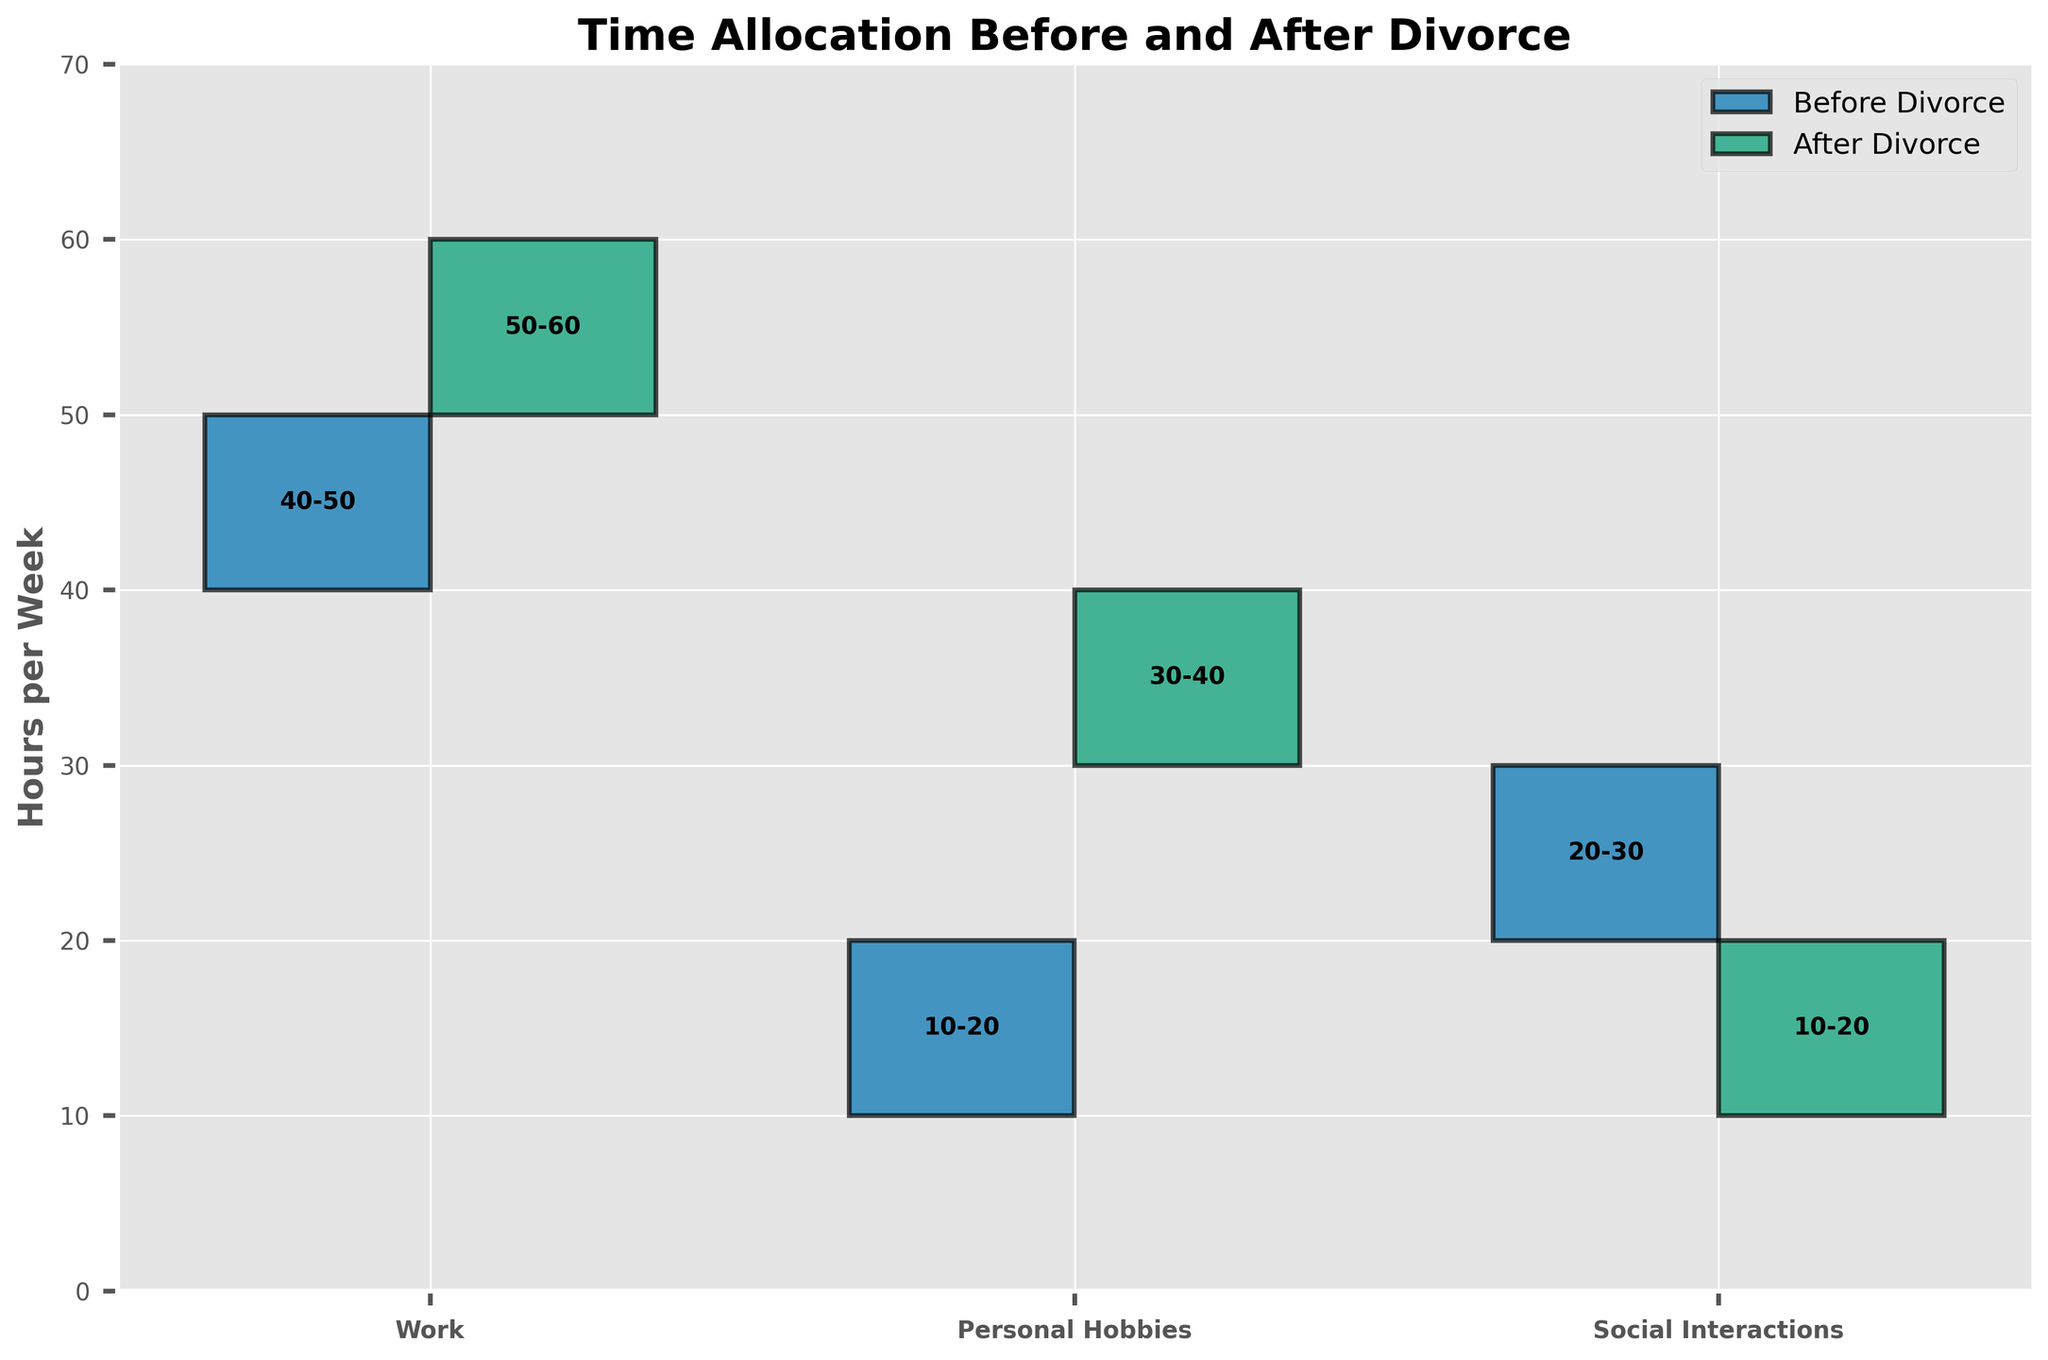What's the title of the figure? The title is displayed at the top of the figure. It reads "Time Allocation Before and After Divorce".
Answer: Time Allocation Before and After Divorce What activity saw the biggest increase in hours after the divorce? Compare the min and max values of each activity before and after the divorce. Personal Hobbies increased from 10-20 to 30-40 hours.
Answer: Personal Hobbies What's the range of hours dedicated to work after the divorce? The range of hours is shown by the bars labeled "After Divorce" under the "Work" category. It spans from 50 to 60 hours.
Answer: 50-60 hours How many activities are compared in the figure? Count the unique labels on the x-axis, which represent each activity.
Answer: 3 activities Which activity experienced the largest decrease in hours after the divorce? Compare the min and max values for each activity before and after the divorce, Social Interactions decreased from 20-30 hours to 10-20 hours.
Answer: Social Interactions How much time, on average, did you spend on personal hobbies before the divorce? The average can be found by taking the midpoint between the minimum and maximum values for Personal Hobbies before divorce (10 and 20). This midpoint is (10+20)/2 = 15 hours.
Answer: 15 hours Which activity had a more consistent (narrower range) time allocation before than after the divorce? Compare the range width (max value minus min value) for each activity before and after the divorce. The range for Personal Hobbies was narrower before (10) compared to after (10).
Answer: Personal Hobbies Do you spend less or more time on social interactions after the divorce compared to before? Compare the min and max value ranges of the "Social Interactions" before and after the divorce. After the divorce, the range is lower (10-20 hours) compared to before (20-30 hours).
Answer: Less What was the total range covered by work, personal hobbies, and social interactions before the divorce? Add the min and max values of all three activities before the divorce: Work (40-50), Personal Hobbies (10-20), Social Interactions (20-30). The total minimum is 40+10+20 = 70, and the total maximum is 50+20+30 = 100.
Answer: 70-100 Looking at the ranges, which activity has the most variability after the divorce? Identify which activity has the largest difference between min and max values after the divorce. Both Work and Personal Hobbies have a range of 10 hours each, while Social Interactions has a variability of 10 hours.
Answer: Tie between all activities 